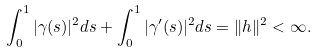<formula> <loc_0><loc_0><loc_500><loc_500>\int _ { 0 } ^ { 1 } | \gamma ( s ) | ^ { 2 } d s + \int _ { 0 } ^ { 1 } | \gamma ^ { \prime } ( s ) | ^ { 2 } d s = \| h \| ^ { 2 } < \infty .</formula> 